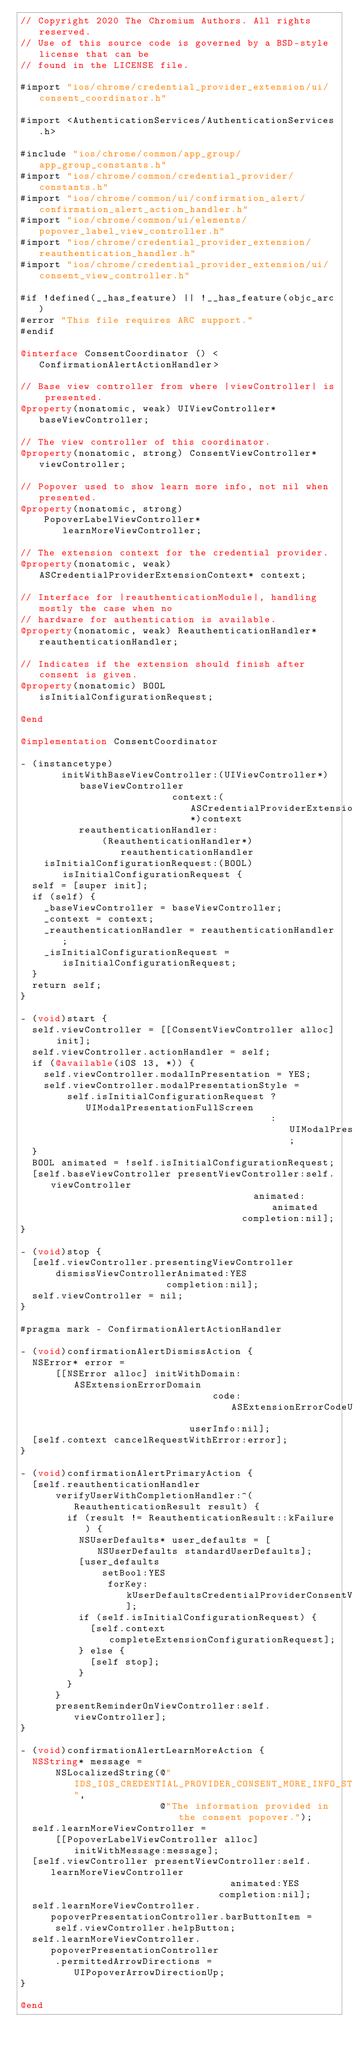<code> <loc_0><loc_0><loc_500><loc_500><_ObjectiveC_>// Copyright 2020 The Chromium Authors. All rights reserved.
// Use of this source code is governed by a BSD-style license that can be
// found in the LICENSE file.

#import "ios/chrome/credential_provider_extension/ui/consent_coordinator.h"

#import <AuthenticationServices/AuthenticationServices.h>

#include "ios/chrome/common/app_group/app_group_constants.h"
#import "ios/chrome/common/credential_provider/constants.h"
#import "ios/chrome/common/ui/confirmation_alert/confirmation_alert_action_handler.h"
#import "ios/chrome/common/ui/elements/popover_label_view_controller.h"
#import "ios/chrome/credential_provider_extension/reauthentication_handler.h"
#import "ios/chrome/credential_provider_extension/ui/consent_view_controller.h"

#if !defined(__has_feature) || !__has_feature(objc_arc)
#error "This file requires ARC support."
#endif

@interface ConsentCoordinator () <ConfirmationAlertActionHandler>

// Base view controller from where |viewController| is presented.
@property(nonatomic, weak) UIViewController* baseViewController;

// The view controller of this coordinator.
@property(nonatomic, strong) ConsentViewController* viewController;

// Popover used to show learn more info, not nil when presented.
@property(nonatomic, strong)
    PopoverLabelViewController* learnMoreViewController;

// The extension context for the credential provider.
@property(nonatomic, weak) ASCredentialProviderExtensionContext* context;

// Interface for |reauthenticationModule|, handling mostly the case when no
// hardware for authentication is available.
@property(nonatomic, weak) ReauthenticationHandler* reauthenticationHandler;

// Indicates if the extension should finish after consent is given.
@property(nonatomic) BOOL isInitialConfigurationRequest;

@end

@implementation ConsentCoordinator

- (instancetype)
       initWithBaseViewController:(UIViewController*)baseViewController
                          context:(ASCredentialProviderExtensionContext*)context
          reauthenticationHandler:
              (ReauthenticationHandler*)reauthenticationHandler
    isInitialConfigurationRequest:(BOOL)isInitialConfigurationRequest {
  self = [super init];
  if (self) {
    _baseViewController = baseViewController;
    _context = context;
    _reauthenticationHandler = reauthenticationHandler;
    _isInitialConfigurationRequest = isInitialConfigurationRequest;
  }
  return self;
}

- (void)start {
  self.viewController = [[ConsentViewController alloc] init];
  self.viewController.actionHandler = self;
  if (@available(iOS 13, *)) {
    self.viewController.modalInPresentation = YES;
    self.viewController.modalPresentationStyle =
        self.isInitialConfigurationRequest ? UIModalPresentationFullScreen
                                           : UIModalPresentationAutomatic;
  }
  BOOL animated = !self.isInitialConfigurationRequest;
  [self.baseViewController presentViewController:self.viewController
                                        animated:animated
                                      completion:nil];
}

- (void)stop {
  [self.viewController.presentingViewController
      dismissViewControllerAnimated:YES
                         completion:nil];
  self.viewController = nil;
}

#pragma mark - ConfirmationAlertActionHandler

- (void)confirmationAlertDismissAction {
  NSError* error =
      [[NSError alloc] initWithDomain:ASExtensionErrorDomain
                                 code:ASExtensionErrorCodeUserCanceled
                             userInfo:nil];
  [self.context cancelRequestWithError:error];
}

- (void)confirmationAlertPrimaryAction {
  [self.reauthenticationHandler
      verifyUserWithCompletionHandler:^(ReauthenticationResult result) {
        if (result != ReauthenticationResult::kFailure) {
          NSUserDefaults* user_defaults = [NSUserDefaults standardUserDefaults];
          [user_defaults
              setBool:YES
               forKey:kUserDefaultsCredentialProviderConsentVerified];
          if (self.isInitialConfigurationRequest) {
            [self.context completeExtensionConfigurationRequest];
          } else {
            [self stop];
          }
        }
      }
      presentReminderOnViewController:self.viewController];
}

- (void)confirmationAlertLearnMoreAction {
  NSString* message =
      NSLocalizedString(@"IDS_IOS_CREDENTIAL_PROVIDER_CONSENT_MORE_INFO_STRING",
                        @"The information provided in the consent popover.");
  self.learnMoreViewController =
      [[PopoverLabelViewController alloc] initWithMessage:message];
  [self.viewController presentViewController:self.learnMoreViewController
                                    animated:YES
                                  completion:nil];
  self.learnMoreViewController.popoverPresentationController.barButtonItem =
      self.viewController.helpButton;
  self.learnMoreViewController.popoverPresentationController
      .permittedArrowDirections = UIPopoverArrowDirectionUp;
}

@end
</code> 